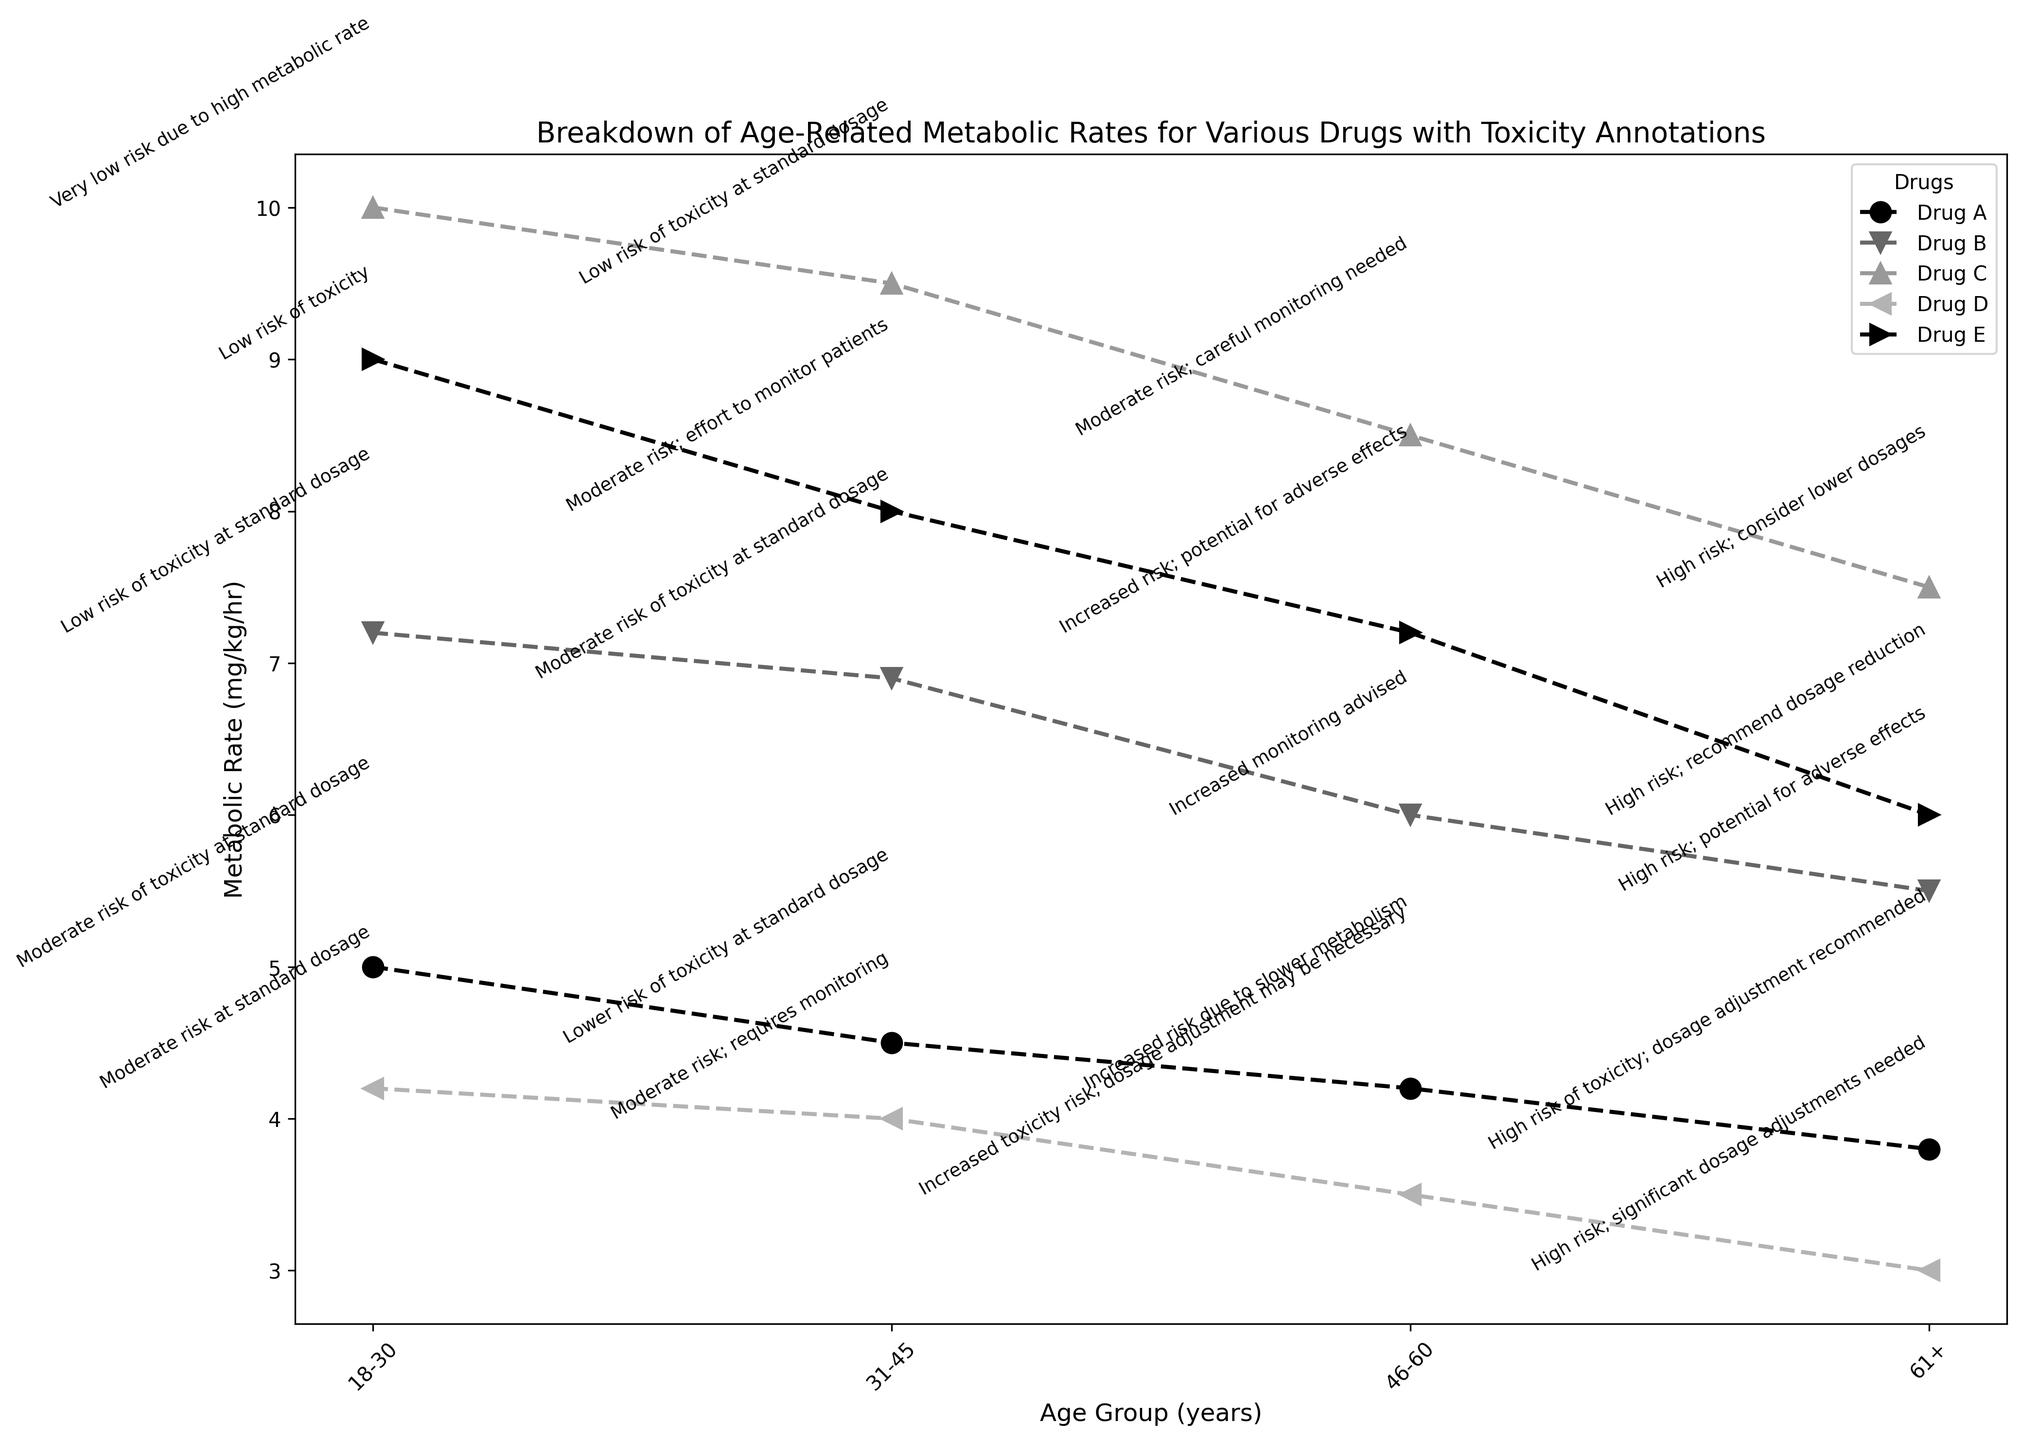What is the trend of metabolic rates for Drug A across different age groups? For Drug A, the metabolic rate decreases as the age group increases. Starting from the highest metabolic rate of 5 mg/kg/hr in the 18-30 age group, it drops to 4.5 mg/kg/hr in the 31-45 age group, 4.2 mg/kg/hr in the 46-60 age group, and finally to 3.8 mg/kg/hr in the 61+ age group.
Answer: Decreasing trend Which drug has the highest metabolic rate in the 18-30 age group? Comparing the metabolic rates in the 18-30 age group, Drug A has 5, Drug B has 7.2, Drug C has 10, Drug D has 4.2, and Drug E has 9. Drug C has the highest metabolic rate in this age group.
Answer: Drug C For the 61+ age group, which drug requires significant dosage adjustments due to high toxicity risk? Looking at the annotations for the 61+ age group, the drugs with significant dosage adjustments needed are Drug D and Drug C, both marked with "High risk; significant dosage adjustments needed" or similar annotations.
Answer: Drug D and Drug C What is the average metabolic rate of Drug E across all age groups? The metabolic rates for Drug E are 9.0, 8.0, 7.2, and 6.0 mg/kg/hr for the different age groups. Summing these, we get 9.0 + 8.0 + 7.2 + 6.0 = 30.2. Dividing by the four age groups gives us an average of 30.2 / 4 = 7.55 mg/kg/hr.
Answer: 7.55 mg/kg/hr Compare the toxicity risk annotations for Drug A and Drug B in the 46-60 age group. In the 46-60 age group, Drug A has an annotation stating "Increased risk due to slower metabolism" while Drug B has "Increased monitoring advised." Both drugs imply a higher level of caution but differ slightly in their specific recommendations.
Answer: Both have increased risk but different recommendations Which drug shows the most consistent metabolic rate across all age groups? To determine consistency, we look for the least variation in metabolic rates for each drug across age groups. Drug A: 5, 4.5, 4.2, 3.8; Drug B: 7.2, 6.9, 6.0, 5.5; Drug C: 10, 9.5, 8.5, 7.5; Drug D: 4.2, 4.0, 3.5, 3.0; Drug E: 9.0, 8.0, 7.2, 6.0. Drug D shows the smallest variation (4.2 to 3.0), indicating it is the most consistent.
Answer: Drug D How does the toxicity risk annotation for Drug C change from the 18-30 age group to the 61+ age group? The toxicity risk annotation for Drug C starts at "Very low risk due to high metabolic rate" in the 18-30 age group, and changes to "High risk; consider lower dosages" in the 61+ age group, indicating a significant increase in risk as age increases.
Answer: From very low risk to high risk 